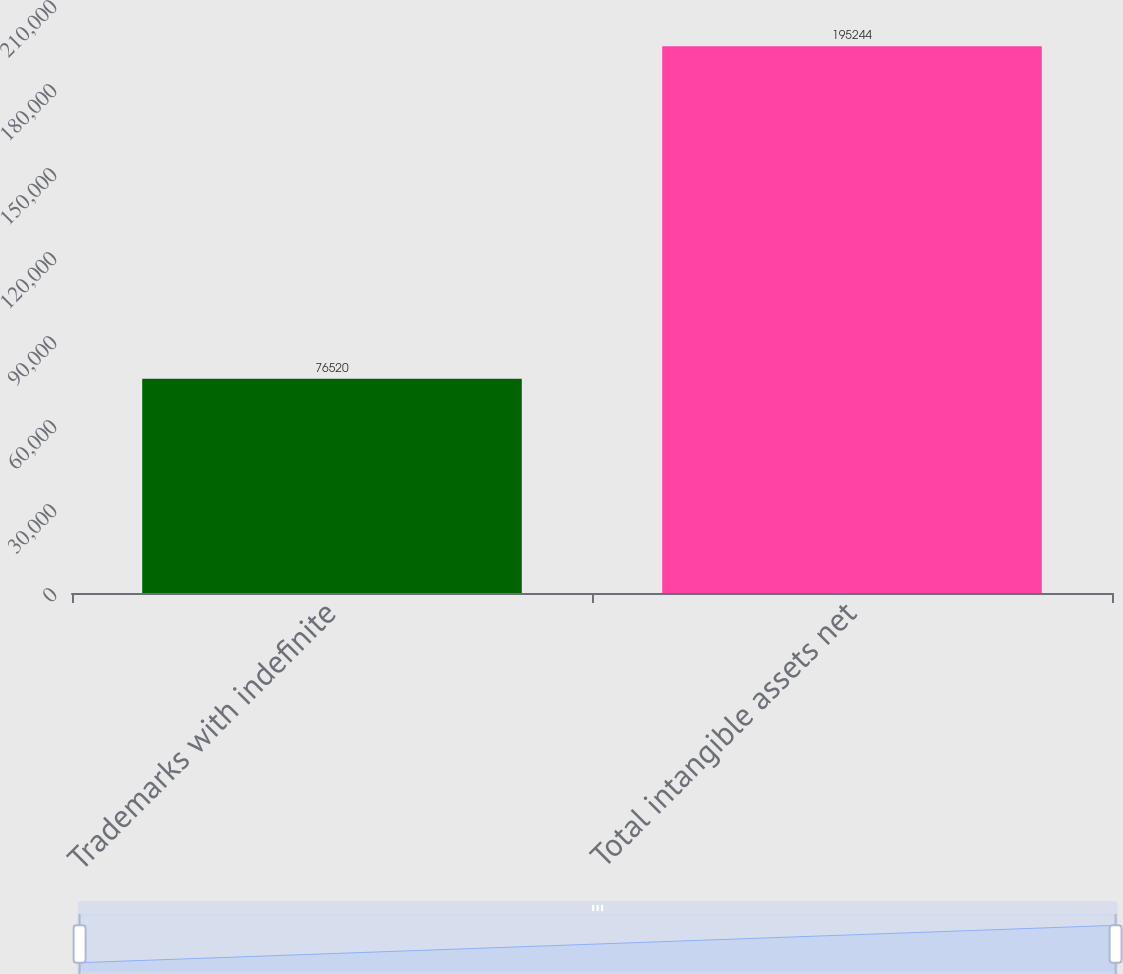Convert chart. <chart><loc_0><loc_0><loc_500><loc_500><bar_chart><fcel>Trademarks with indefinite<fcel>Total intangible assets net<nl><fcel>76520<fcel>195244<nl></chart> 